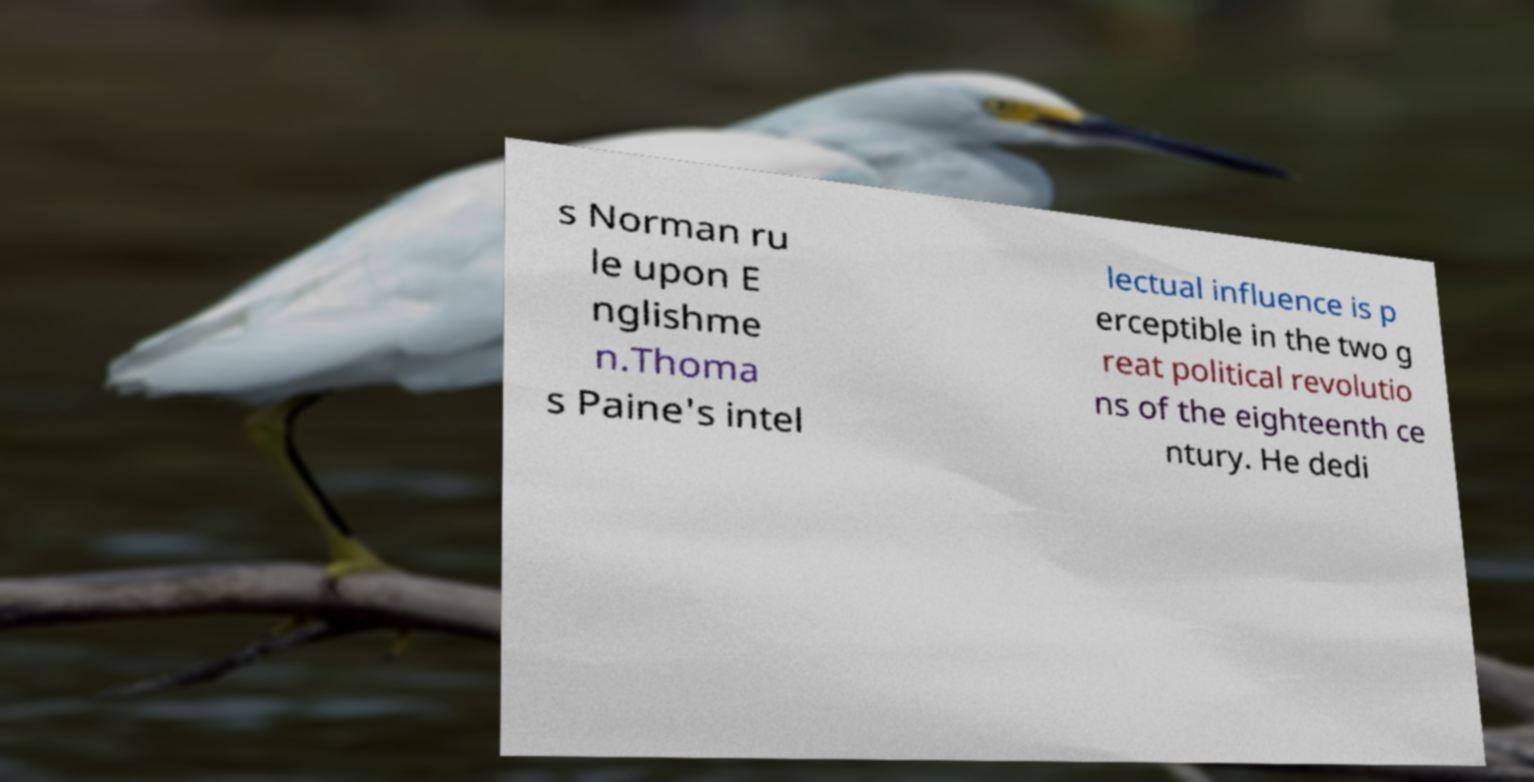What messages or text are displayed in this image? I need them in a readable, typed format. s Norman ru le upon E nglishme n.Thoma s Paine's intel lectual influence is p erceptible in the two g reat political revolutio ns of the eighteenth ce ntury. He dedi 